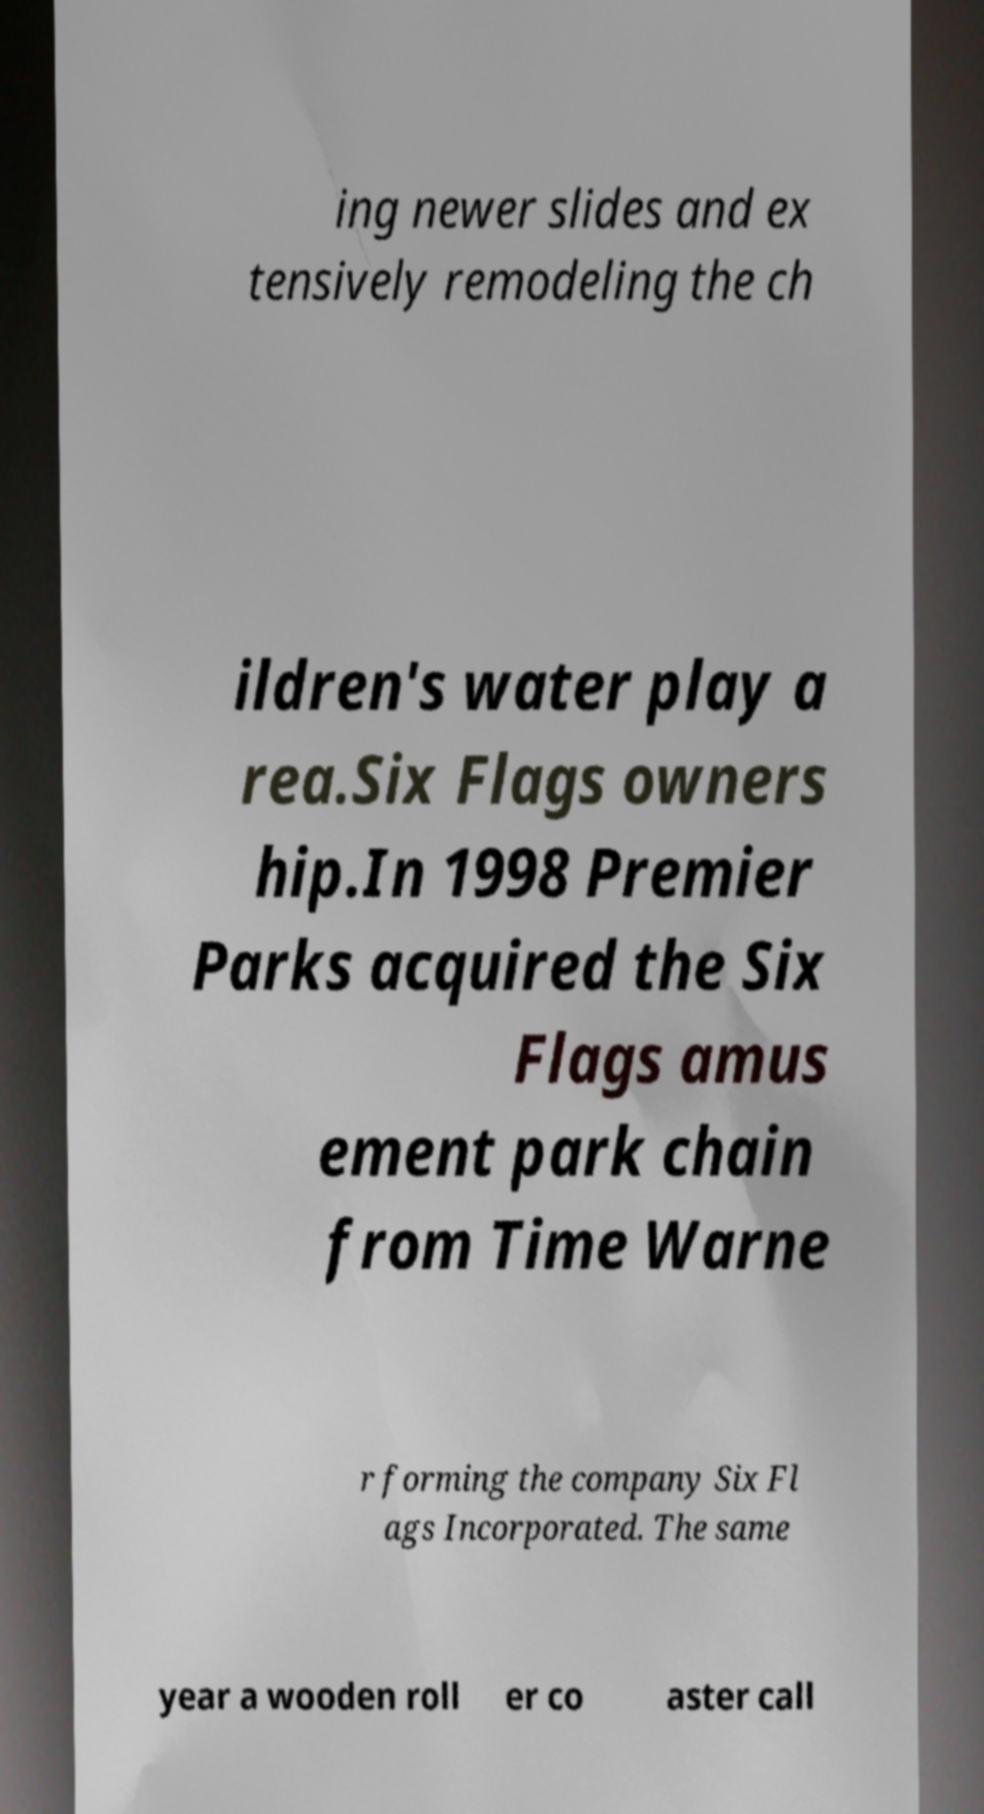Please identify and transcribe the text found in this image. ing newer slides and ex tensively remodeling the ch ildren's water play a rea.Six Flags owners hip.In 1998 Premier Parks acquired the Six Flags amus ement park chain from Time Warne r forming the company Six Fl ags Incorporated. The same year a wooden roll er co aster call 